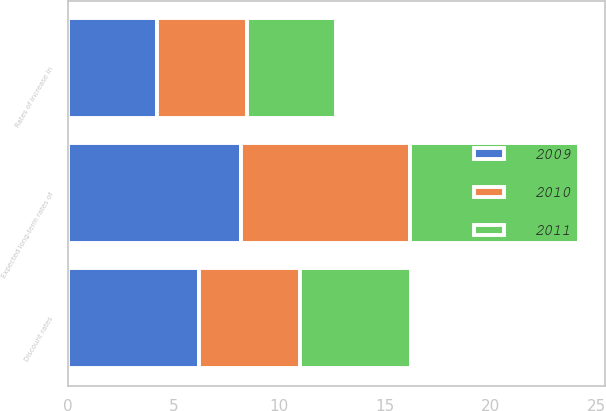Convert chart to OTSL. <chart><loc_0><loc_0><loc_500><loc_500><stacked_bar_chart><ecel><fcel>Discount rates<fcel>Rates of increase in<fcel>Expected long-term rates of<nl><fcel>2010<fcel>4.75<fcel>4.25<fcel>8<nl><fcel>2011<fcel>5.28<fcel>4.22<fcel>8<nl><fcel>2009<fcel>6.22<fcel>4.23<fcel>8.2<nl></chart> 